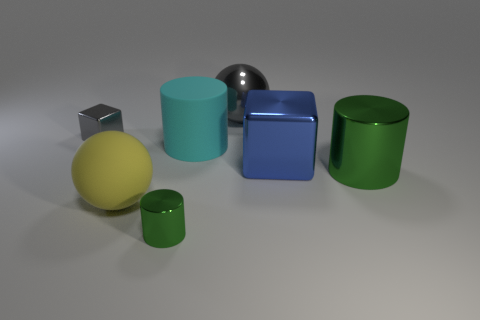Does the metal sphere have the same color as the cube behind the large shiny cube?
Your answer should be very brief. Yes. What size is the other object that is made of the same material as the yellow object?
Your answer should be very brief. Large. The ball that is the same color as the small block is what size?
Offer a terse response. Large. Is the small metal cylinder the same color as the big metal cylinder?
Your answer should be compact. Yes. Is there a shiny block that is to the left of the block that is to the right of the small thing in front of the large blue thing?
Your answer should be compact. Yes. How many red shiny objects have the same size as the cyan rubber object?
Offer a very short reply. 0. Does the green cylinder in front of the large green metal thing have the same size as the green metallic cylinder to the right of the big blue thing?
Your answer should be compact. No. There is a thing that is right of the rubber sphere and in front of the large green metal thing; what shape is it?
Give a very brief answer. Cylinder. Are there any objects of the same color as the metal sphere?
Your answer should be very brief. Yes. Are there any large purple rubber objects?
Give a very brief answer. No. 